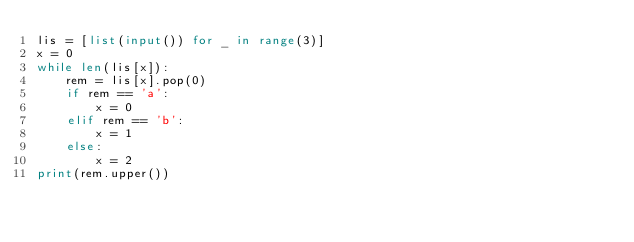<code> <loc_0><loc_0><loc_500><loc_500><_Python_>lis = [list(input()) for _ in range(3)]
x = 0
while len(lis[x]):
    rem = lis[x].pop(0)
    if rem == 'a':
        x = 0
    elif rem == 'b':
        x = 1
    else:
        x = 2
print(rem.upper())</code> 